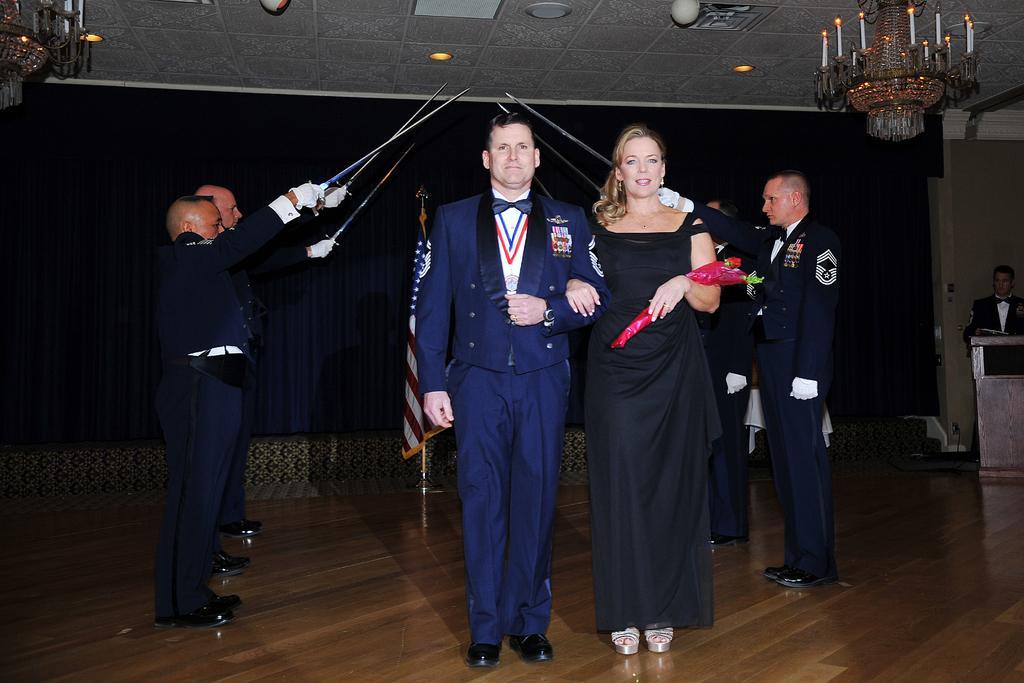How would you summarize this image in a sentence or two? In this picture I can see a man and woman standing on the surface. I can see a few people holding the weapons. I can see the chandeliers. I can see light arrangements on the roof. 